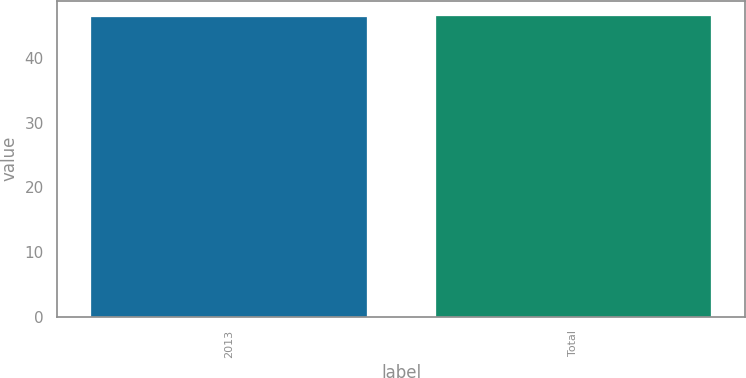Convert chart. <chart><loc_0><loc_0><loc_500><loc_500><bar_chart><fcel>2013<fcel>Total<nl><fcel>46.4<fcel>46.5<nl></chart> 